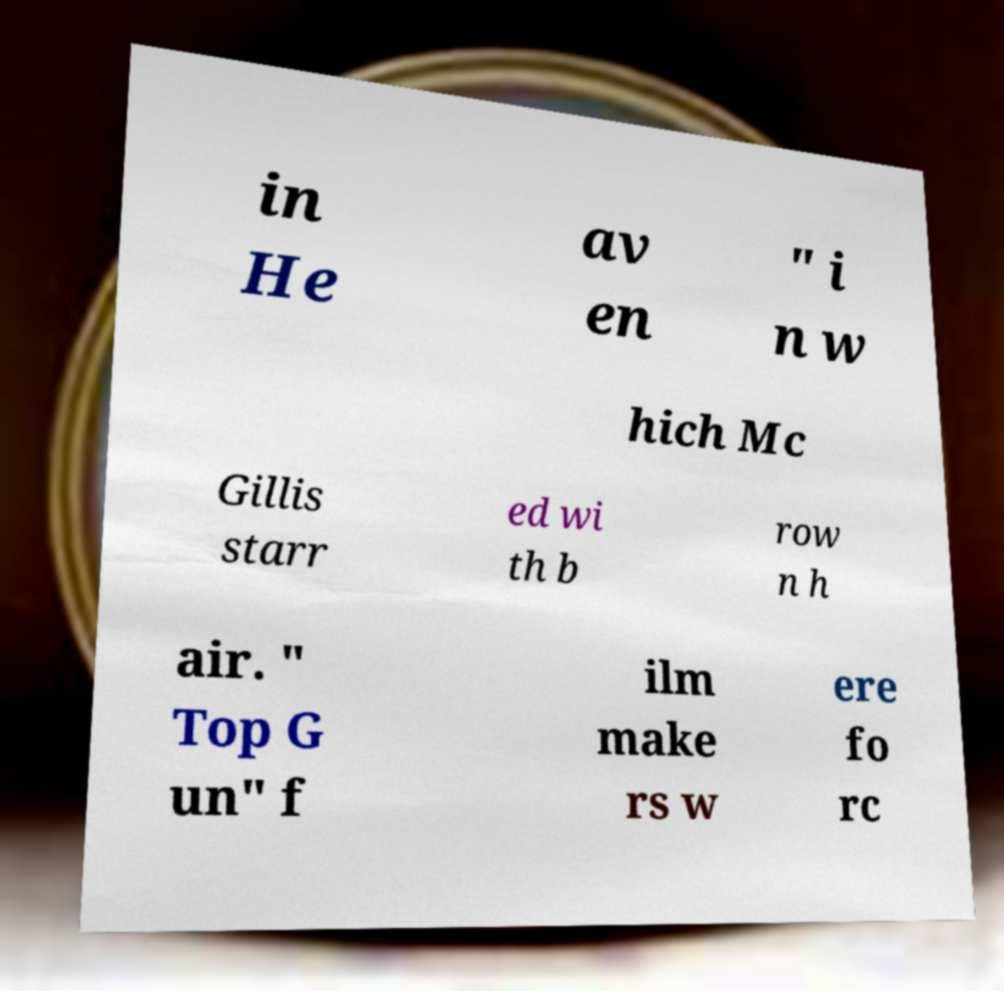Could you assist in decoding the text presented in this image and type it out clearly? in He av en " i n w hich Mc Gillis starr ed wi th b row n h air. " Top G un" f ilm make rs w ere fo rc 